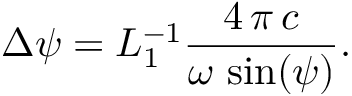<formula> <loc_0><loc_0><loc_500><loc_500>\Delta \psi = L _ { 1 } ^ { - 1 } \frac { 4 \, \pi \, c } { \omega \, \sin ( \psi ) } .</formula> 